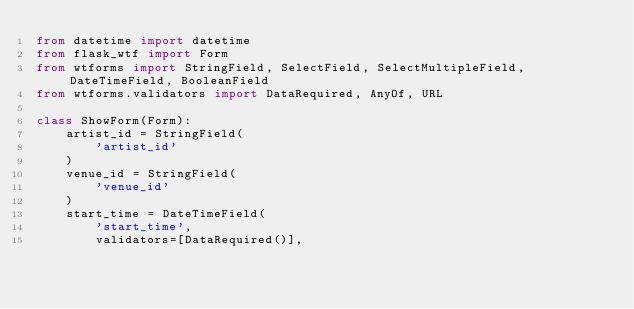Convert code to text. <code><loc_0><loc_0><loc_500><loc_500><_Python_>from datetime import datetime
from flask_wtf import Form
from wtforms import StringField, SelectField, SelectMultipleField, DateTimeField, BooleanField
from wtforms.validators import DataRequired, AnyOf, URL

class ShowForm(Form):
    artist_id = StringField(
        'artist_id'
    )
    venue_id = StringField(
        'venue_id'
    )
    start_time = DateTimeField(
        'start_time',
        validators=[DataRequired()],</code> 